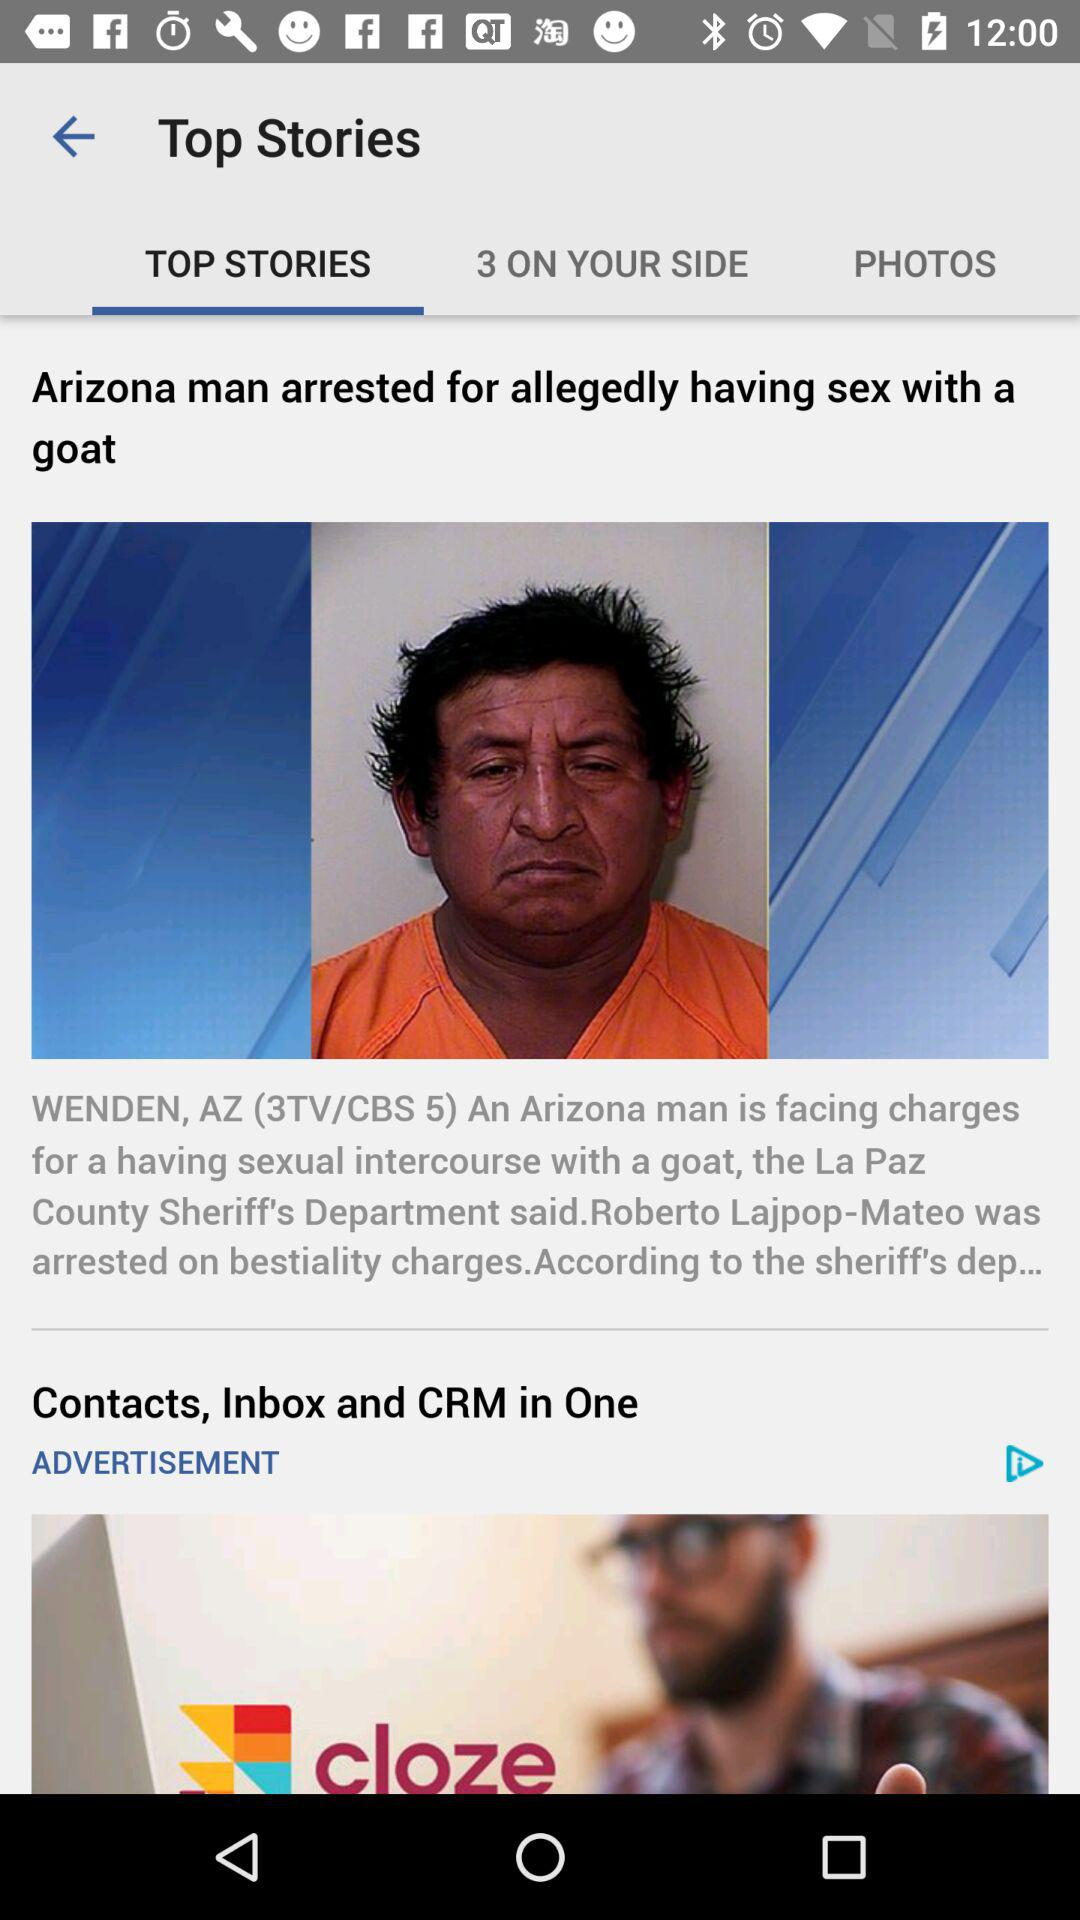When was the top story published?
When the provided information is insufficient, respond with <no answer>. <no answer> 